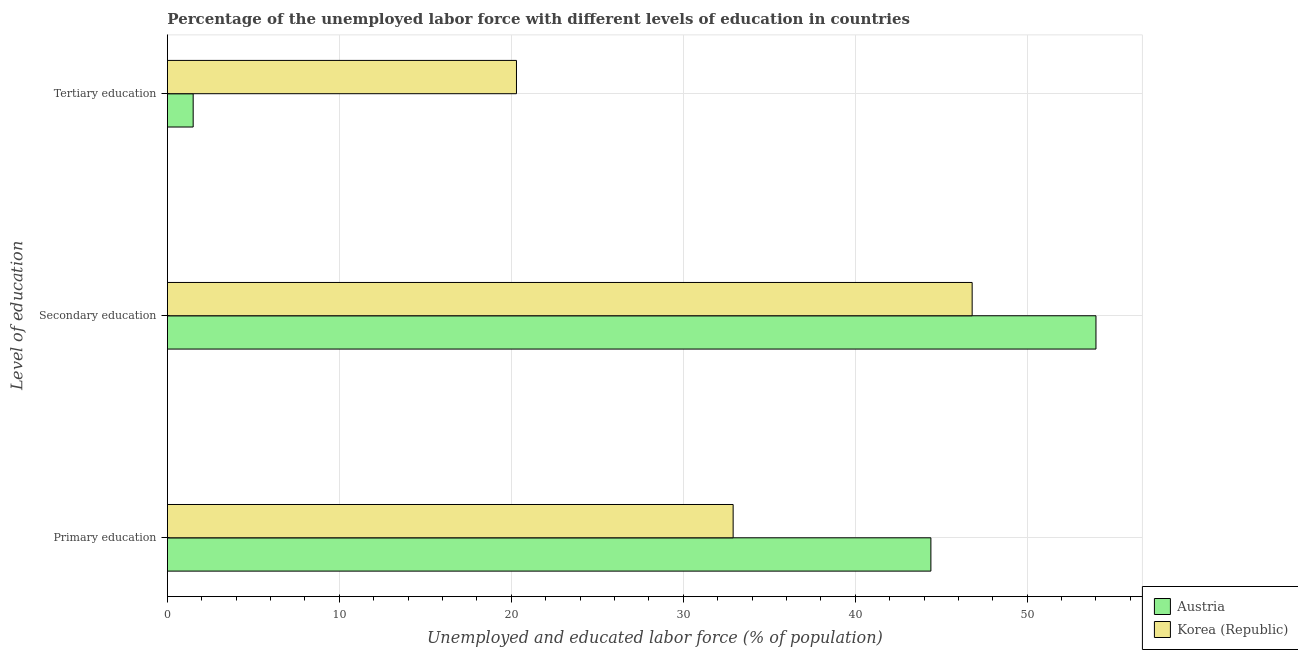Are the number of bars per tick equal to the number of legend labels?
Your answer should be very brief. Yes. What is the label of the 3rd group of bars from the top?
Your answer should be very brief. Primary education. What is the percentage of labor force who received primary education in Austria?
Your answer should be compact. 44.4. Across all countries, what is the maximum percentage of labor force who received secondary education?
Your response must be concise. 54. Across all countries, what is the minimum percentage of labor force who received primary education?
Ensure brevity in your answer.  32.9. What is the total percentage of labor force who received secondary education in the graph?
Ensure brevity in your answer.  100.8. What is the difference between the percentage of labor force who received tertiary education in Austria and that in Korea (Republic)?
Your answer should be very brief. -18.8. What is the difference between the percentage of labor force who received secondary education in Austria and the percentage of labor force who received tertiary education in Korea (Republic)?
Your answer should be compact. 33.7. What is the average percentage of labor force who received tertiary education per country?
Keep it short and to the point. 10.9. What is the difference between the percentage of labor force who received secondary education and percentage of labor force who received tertiary education in Korea (Republic)?
Keep it short and to the point. 26.5. In how many countries, is the percentage of labor force who received primary education greater than 48 %?
Your response must be concise. 0. What is the ratio of the percentage of labor force who received secondary education in Austria to that in Korea (Republic)?
Your response must be concise. 1.15. What is the difference between the highest and the second highest percentage of labor force who received secondary education?
Give a very brief answer. 7.2. What is the difference between the highest and the lowest percentage of labor force who received primary education?
Your answer should be compact. 11.5. Is the sum of the percentage of labor force who received secondary education in Austria and Korea (Republic) greater than the maximum percentage of labor force who received tertiary education across all countries?
Your answer should be compact. Yes. Are the values on the major ticks of X-axis written in scientific E-notation?
Keep it short and to the point. No. Where does the legend appear in the graph?
Your response must be concise. Bottom right. How many legend labels are there?
Make the answer very short. 2. How are the legend labels stacked?
Make the answer very short. Vertical. What is the title of the graph?
Keep it short and to the point. Percentage of the unemployed labor force with different levels of education in countries. What is the label or title of the X-axis?
Keep it short and to the point. Unemployed and educated labor force (% of population). What is the label or title of the Y-axis?
Ensure brevity in your answer.  Level of education. What is the Unemployed and educated labor force (% of population) of Austria in Primary education?
Offer a very short reply. 44.4. What is the Unemployed and educated labor force (% of population) in Korea (Republic) in Primary education?
Offer a very short reply. 32.9. What is the Unemployed and educated labor force (% of population) in Korea (Republic) in Secondary education?
Keep it short and to the point. 46.8. What is the Unemployed and educated labor force (% of population) of Austria in Tertiary education?
Offer a very short reply. 1.5. What is the Unemployed and educated labor force (% of population) of Korea (Republic) in Tertiary education?
Provide a succinct answer. 20.3. Across all Level of education, what is the maximum Unemployed and educated labor force (% of population) of Korea (Republic)?
Provide a short and direct response. 46.8. Across all Level of education, what is the minimum Unemployed and educated labor force (% of population) in Korea (Republic)?
Provide a short and direct response. 20.3. What is the total Unemployed and educated labor force (% of population) of Austria in the graph?
Make the answer very short. 99.9. What is the total Unemployed and educated labor force (% of population) in Korea (Republic) in the graph?
Provide a succinct answer. 100. What is the difference between the Unemployed and educated labor force (% of population) in Austria in Primary education and that in Tertiary education?
Offer a very short reply. 42.9. What is the difference between the Unemployed and educated labor force (% of population) in Austria in Secondary education and that in Tertiary education?
Your answer should be very brief. 52.5. What is the difference between the Unemployed and educated labor force (% of population) in Austria in Primary education and the Unemployed and educated labor force (% of population) in Korea (Republic) in Tertiary education?
Ensure brevity in your answer.  24.1. What is the difference between the Unemployed and educated labor force (% of population) in Austria in Secondary education and the Unemployed and educated labor force (% of population) in Korea (Republic) in Tertiary education?
Your answer should be compact. 33.7. What is the average Unemployed and educated labor force (% of population) of Austria per Level of education?
Offer a terse response. 33.3. What is the average Unemployed and educated labor force (% of population) of Korea (Republic) per Level of education?
Your answer should be compact. 33.33. What is the difference between the Unemployed and educated labor force (% of population) in Austria and Unemployed and educated labor force (% of population) in Korea (Republic) in Secondary education?
Provide a succinct answer. 7.2. What is the difference between the Unemployed and educated labor force (% of population) of Austria and Unemployed and educated labor force (% of population) of Korea (Republic) in Tertiary education?
Provide a short and direct response. -18.8. What is the ratio of the Unemployed and educated labor force (% of population) of Austria in Primary education to that in Secondary education?
Keep it short and to the point. 0.82. What is the ratio of the Unemployed and educated labor force (% of population) of Korea (Republic) in Primary education to that in Secondary education?
Keep it short and to the point. 0.7. What is the ratio of the Unemployed and educated labor force (% of population) in Austria in Primary education to that in Tertiary education?
Your response must be concise. 29.6. What is the ratio of the Unemployed and educated labor force (% of population) of Korea (Republic) in Primary education to that in Tertiary education?
Ensure brevity in your answer.  1.62. What is the ratio of the Unemployed and educated labor force (% of population) of Korea (Republic) in Secondary education to that in Tertiary education?
Ensure brevity in your answer.  2.31. What is the difference between the highest and the lowest Unemployed and educated labor force (% of population) in Austria?
Make the answer very short. 52.5. 